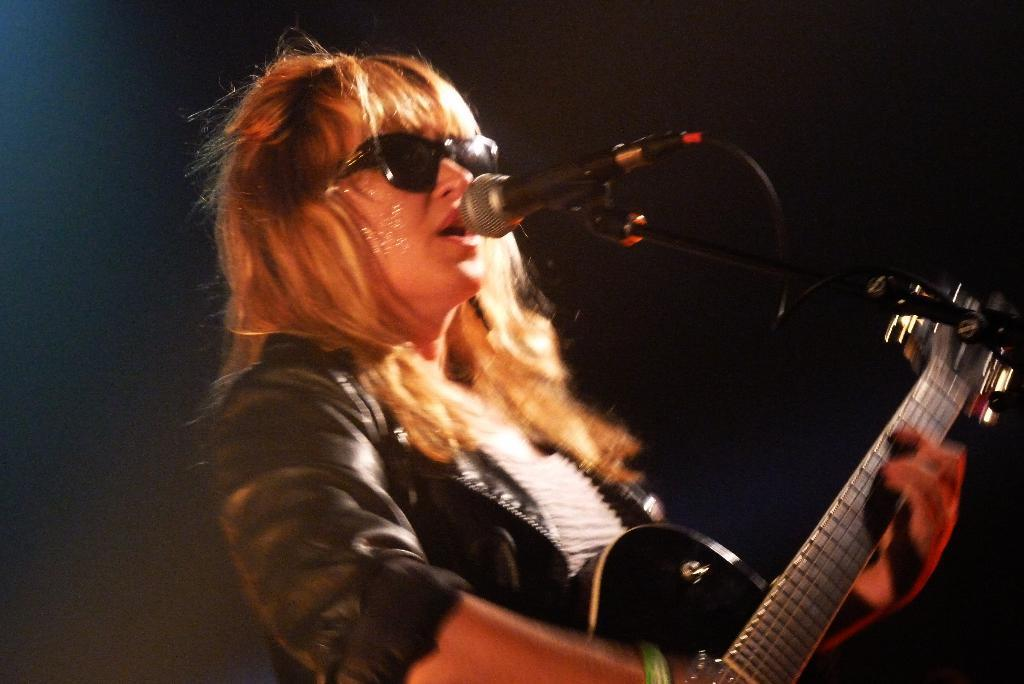What is the person in the image holding? The person is holding a guitar. What activity is the person engaged in? The person is speaking into a microphone. What type of potato is being used as a seat for the person in the image? There is no potato present in the image, and the person is not sitting on any object. 